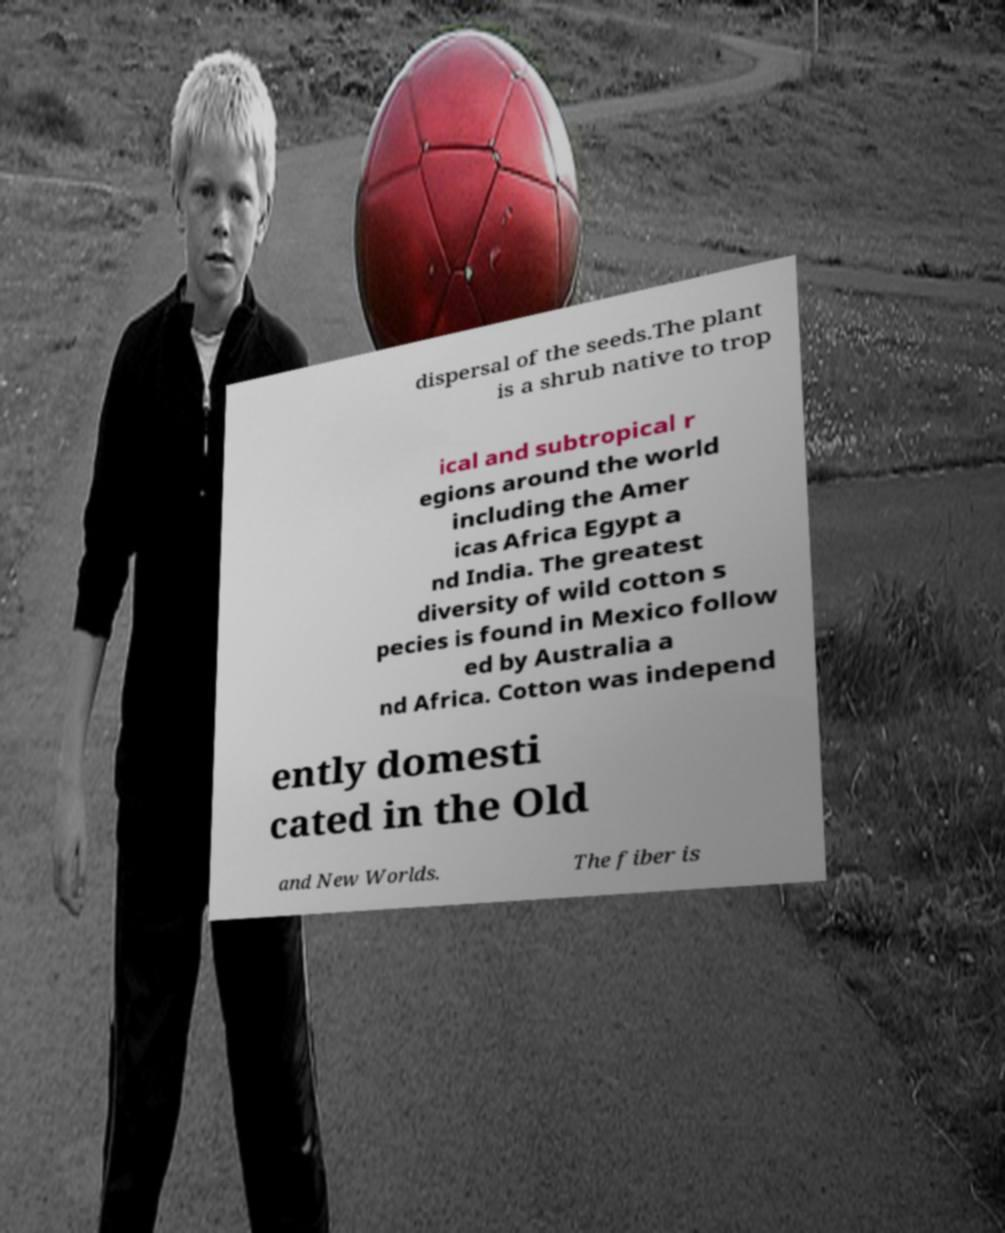I need the written content from this picture converted into text. Can you do that? dispersal of the seeds.The plant is a shrub native to trop ical and subtropical r egions around the world including the Amer icas Africa Egypt a nd India. The greatest diversity of wild cotton s pecies is found in Mexico follow ed by Australia a nd Africa. Cotton was independ ently domesti cated in the Old and New Worlds. The fiber is 